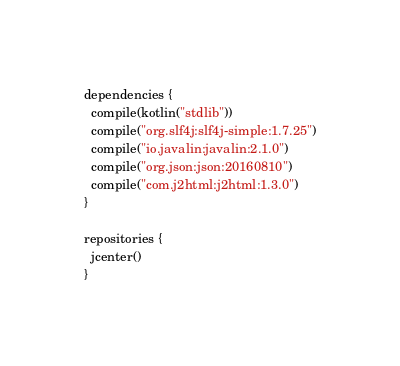Convert code to text. <code><loc_0><loc_0><loc_500><loc_500><_Kotlin_>
dependencies {
  compile(kotlin("stdlib"))
  compile("org.slf4j:slf4j-simple:1.7.25")
  compile("io.javalin:javalin:2.1.0")
  compile("org.json:json:20160810")
  compile("com.j2html:j2html:1.3.0")
}

repositories {
  jcenter()
}
</code> 